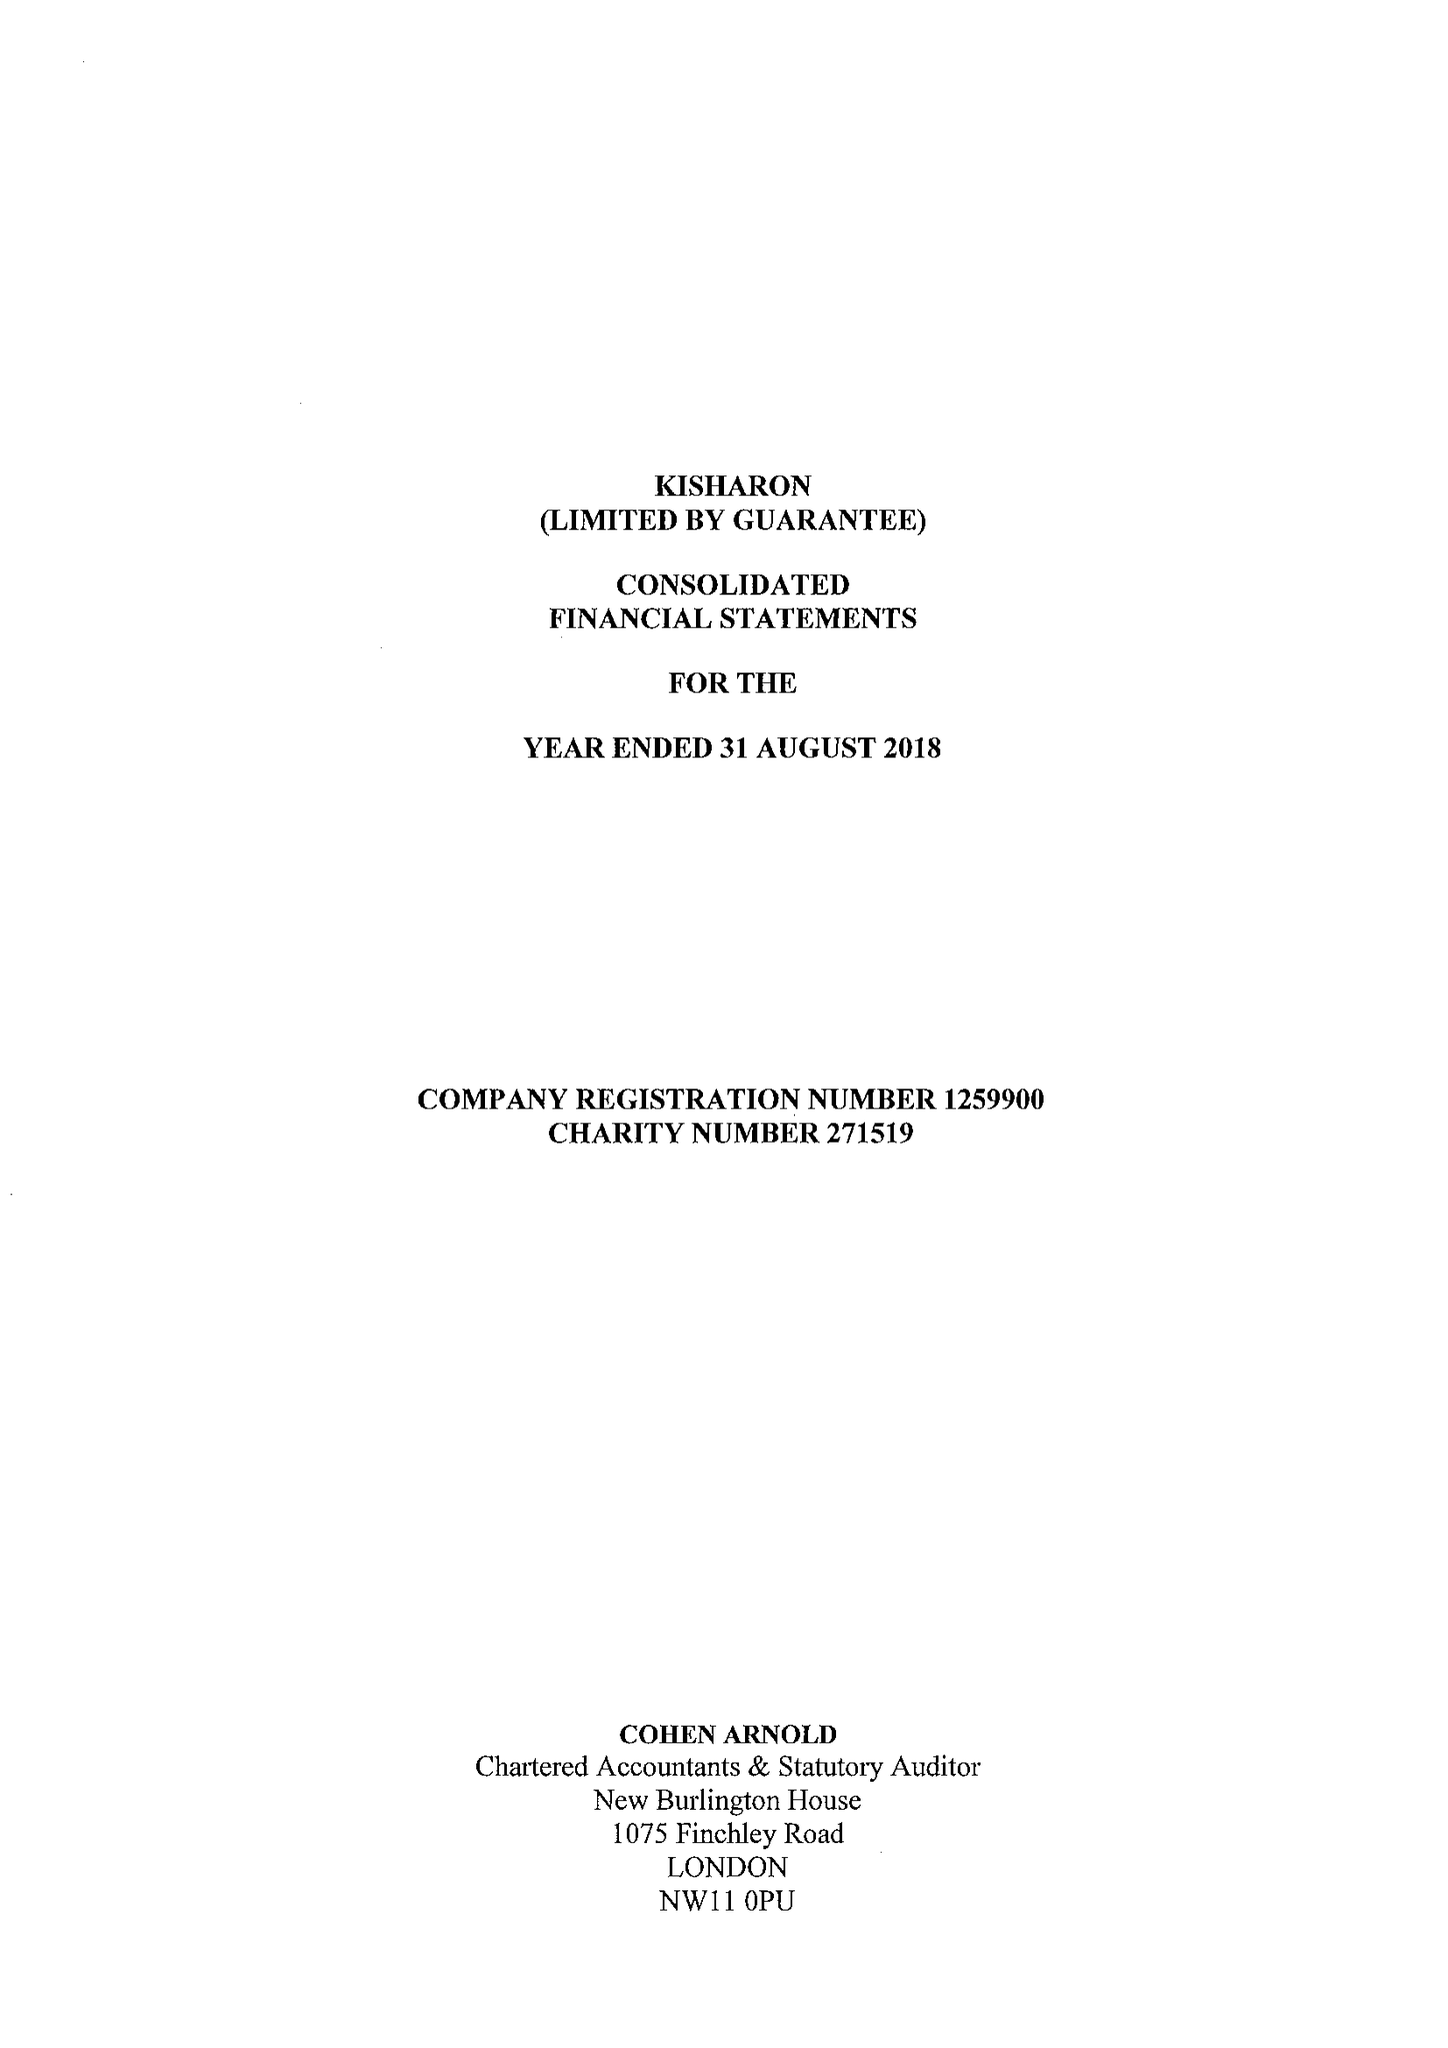What is the value for the spending_annually_in_british_pounds?
Answer the question using a single word or phrase. 10690794.00 